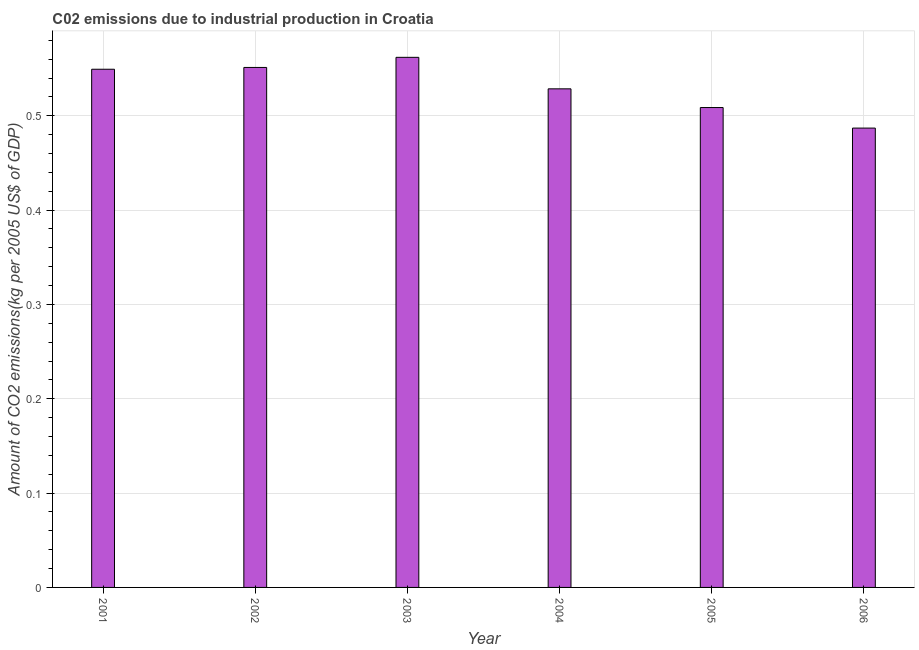What is the title of the graph?
Offer a terse response. C02 emissions due to industrial production in Croatia. What is the label or title of the Y-axis?
Make the answer very short. Amount of CO2 emissions(kg per 2005 US$ of GDP). What is the amount of co2 emissions in 2004?
Your answer should be compact. 0.53. Across all years, what is the maximum amount of co2 emissions?
Offer a very short reply. 0.56. Across all years, what is the minimum amount of co2 emissions?
Provide a short and direct response. 0.49. What is the sum of the amount of co2 emissions?
Provide a succinct answer. 3.19. What is the difference between the amount of co2 emissions in 2005 and 2006?
Give a very brief answer. 0.02. What is the average amount of co2 emissions per year?
Make the answer very short. 0.53. What is the median amount of co2 emissions?
Provide a succinct answer. 0.54. What is the ratio of the amount of co2 emissions in 2004 to that in 2006?
Make the answer very short. 1.08. Is the amount of co2 emissions in 2004 less than that in 2005?
Your response must be concise. No. Is the difference between the amount of co2 emissions in 2004 and 2006 greater than the difference between any two years?
Give a very brief answer. No. What is the difference between the highest and the second highest amount of co2 emissions?
Provide a short and direct response. 0.01. What is the difference between the highest and the lowest amount of co2 emissions?
Offer a terse response. 0.08. In how many years, is the amount of co2 emissions greater than the average amount of co2 emissions taken over all years?
Offer a terse response. 3. Are all the bars in the graph horizontal?
Ensure brevity in your answer.  No. How many years are there in the graph?
Provide a succinct answer. 6. What is the difference between two consecutive major ticks on the Y-axis?
Your answer should be very brief. 0.1. Are the values on the major ticks of Y-axis written in scientific E-notation?
Provide a succinct answer. No. What is the Amount of CO2 emissions(kg per 2005 US$ of GDP) of 2001?
Your response must be concise. 0.55. What is the Amount of CO2 emissions(kg per 2005 US$ of GDP) of 2002?
Offer a terse response. 0.55. What is the Amount of CO2 emissions(kg per 2005 US$ of GDP) of 2003?
Keep it short and to the point. 0.56. What is the Amount of CO2 emissions(kg per 2005 US$ of GDP) in 2004?
Ensure brevity in your answer.  0.53. What is the Amount of CO2 emissions(kg per 2005 US$ of GDP) in 2005?
Ensure brevity in your answer.  0.51. What is the Amount of CO2 emissions(kg per 2005 US$ of GDP) of 2006?
Your response must be concise. 0.49. What is the difference between the Amount of CO2 emissions(kg per 2005 US$ of GDP) in 2001 and 2002?
Ensure brevity in your answer.  -0. What is the difference between the Amount of CO2 emissions(kg per 2005 US$ of GDP) in 2001 and 2003?
Your response must be concise. -0.01. What is the difference between the Amount of CO2 emissions(kg per 2005 US$ of GDP) in 2001 and 2004?
Keep it short and to the point. 0.02. What is the difference between the Amount of CO2 emissions(kg per 2005 US$ of GDP) in 2001 and 2005?
Offer a very short reply. 0.04. What is the difference between the Amount of CO2 emissions(kg per 2005 US$ of GDP) in 2001 and 2006?
Give a very brief answer. 0.06. What is the difference between the Amount of CO2 emissions(kg per 2005 US$ of GDP) in 2002 and 2003?
Your answer should be compact. -0.01. What is the difference between the Amount of CO2 emissions(kg per 2005 US$ of GDP) in 2002 and 2004?
Offer a terse response. 0.02. What is the difference between the Amount of CO2 emissions(kg per 2005 US$ of GDP) in 2002 and 2005?
Offer a terse response. 0.04. What is the difference between the Amount of CO2 emissions(kg per 2005 US$ of GDP) in 2002 and 2006?
Provide a succinct answer. 0.06. What is the difference between the Amount of CO2 emissions(kg per 2005 US$ of GDP) in 2003 and 2004?
Offer a terse response. 0.03. What is the difference between the Amount of CO2 emissions(kg per 2005 US$ of GDP) in 2003 and 2005?
Offer a very short reply. 0.05. What is the difference between the Amount of CO2 emissions(kg per 2005 US$ of GDP) in 2003 and 2006?
Provide a succinct answer. 0.08. What is the difference between the Amount of CO2 emissions(kg per 2005 US$ of GDP) in 2004 and 2005?
Offer a terse response. 0.02. What is the difference between the Amount of CO2 emissions(kg per 2005 US$ of GDP) in 2004 and 2006?
Make the answer very short. 0.04. What is the difference between the Amount of CO2 emissions(kg per 2005 US$ of GDP) in 2005 and 2006?
Your answer should be very brief. 0.02. What is the ratio of the Amount of CO2 emissions(kg per 2005 US$ of GDP) in 2001 to that in 2004?
Your answer should be very brief. 1.04. What is the ratio of the Amount of CO2 emissions(kg per 2005 US$ of GDP) in 2001 to that in 2006?
Ensure brevity in your answer.  1.13. What is the ratio of the Amount of CO2 emissions(kg per 2005 US$ of GDP) in 2002 to that in 2004?
Ensure brevity in your answer.  1.04. What is the ratio of the Amount of CO2 emissions(kg per 2005 US$ of GDP) in 2002 to that in 2005?
Give a very brief answer. 1.08. What is the ratio of the Amount of CO2 emissions(kg per 2005 US$ of GDP) in 2002 to that in 2006?
Provide a succinct answer. 1.13. What is the ratio of the Amount of CO2 emissions(kg per 2005 US$ of GDP) in 2003 to that in 2004?
Your answer should be very brief. 1.06. What is the ratio of the Amount of CO2 emissions(kg per 2005 US$ of GDP) in 2003 to that in 2005?
Give a very brief answer. 1.1. What is the ratio of the Amount of CO2 emissions(kg per 2005 US$ of GDP) in 2003 to that in 2006?
Keep it short and to the point. 1.15. What is the ratio of the Amount of CO2 emissions(kg per 2005 US$ of GDP) in 2004 to that in 2005?
Keep it short and to the point. 1.04. What is the ratio of the Amount of CO2 emissions(kg per 2005 US$ of GDP) in 2004 to that in 2006?
Make the answer very short. 1.08. What is the ratio of the Amount of CO2 emissions(kg per 2005 US$ of GDP) in 2005 to that in 2006?
Your answer should be compact. 1.04. 